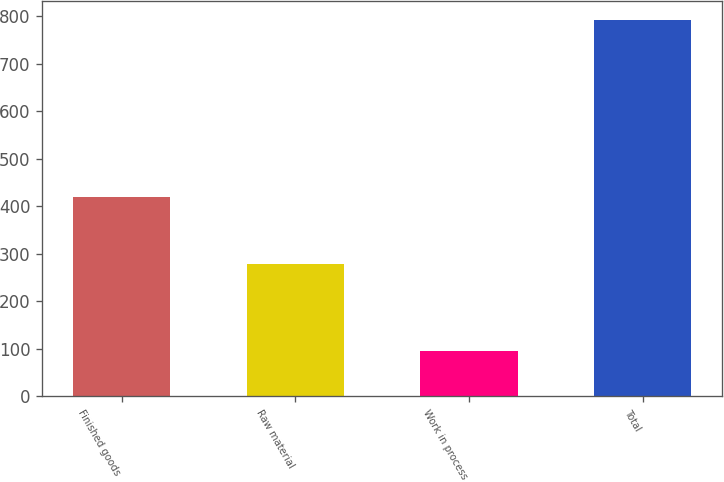<chart> <loc_0><loc_0><loc_500><loc_500><bar_chart><fcel>Finished goods<fcel>Raw material<fcel>Work in process<fcel>Total<nl><fcel>419<fcel>278<fcel>95<fcel>792<nl></chart> 